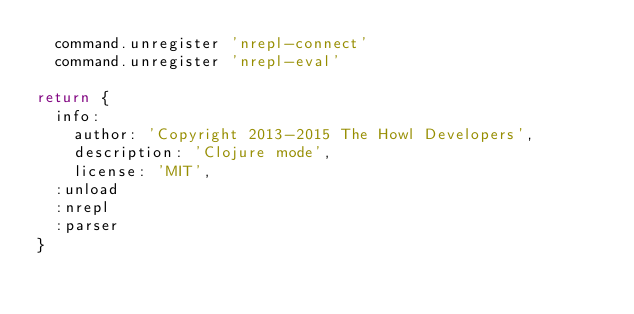Convert code to text. <code><loc_0><loc_0><loc_500><loc_500><_MoonScript_>  command.unregister 'nrepl-connect'
  command.unregister 'nrepl-eval'

return {
  info:
    author: 'Copyright 2013-2015 The Howl Developers',
    description: 'Clojure mode',
    license: 'MIT',
  :unload
  :nrepl
  :parser
}
</code> 